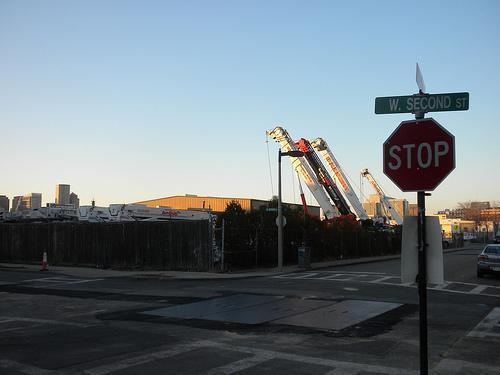How many signs are there?
Give a very brief answer. 3. 